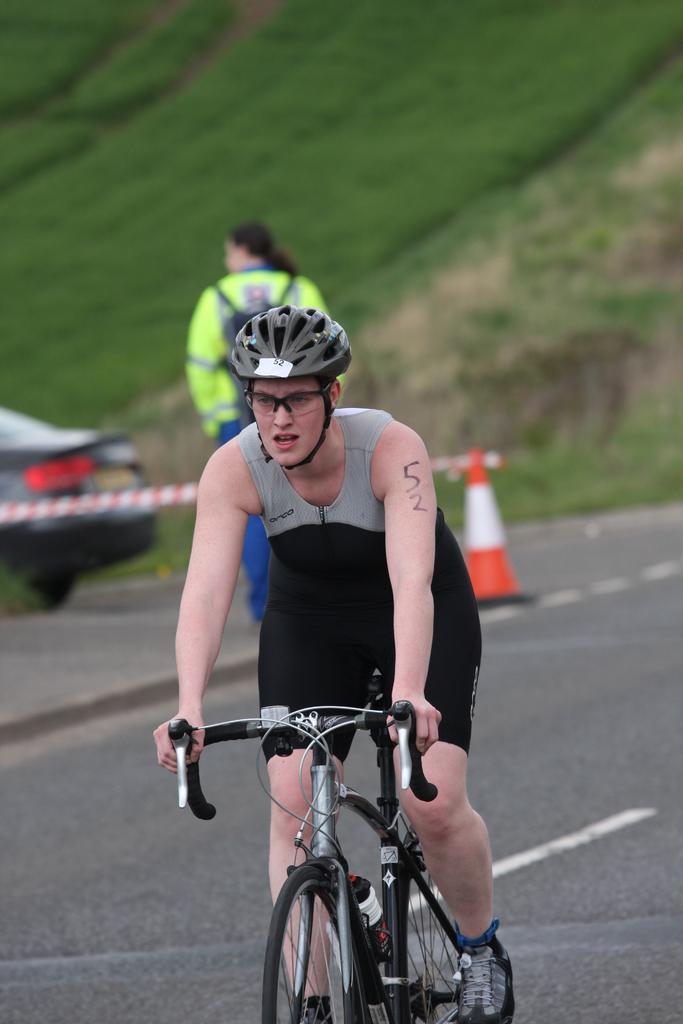What is the man in the image doing? The man is on a cycle in the image. What can be seen in the background of the image? There is a traffic cone, a person, a car, and grass visible in the background of the image. What type of skirt is the man wearing in the image? The man is not wearing a skirt in the image; he is on a cycle. Are there any boots visible on the person in the background of the image? There is no information about the person's footwear in the image, so we cannot determine if they are wearing boots. 